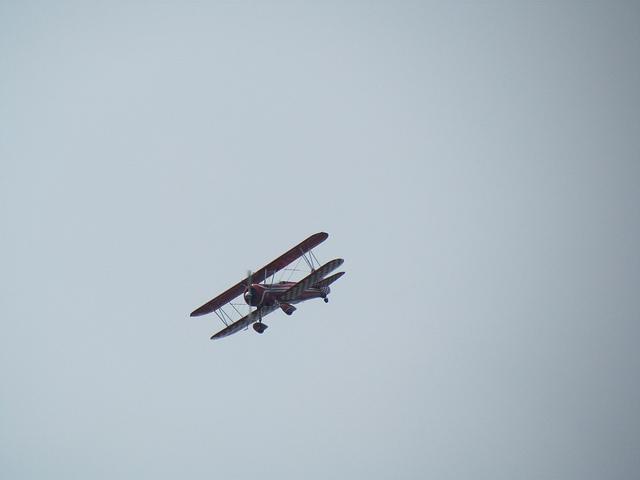How many engines are on the plane?
Give a very brief answer. 1. How many planes are in the sky?
Give a very brief answer. 1. How many engines does this plane have?
Give a very brief answer. 1. How many planes are there?
Give a very brief answer. 1. How many main engines does this vehicle have?
Give a very brief answer. 1. How many planes are in the picture?
Give a very brief answer. 1. How many objects are in this photo?
Give a very brief answer. 1. 